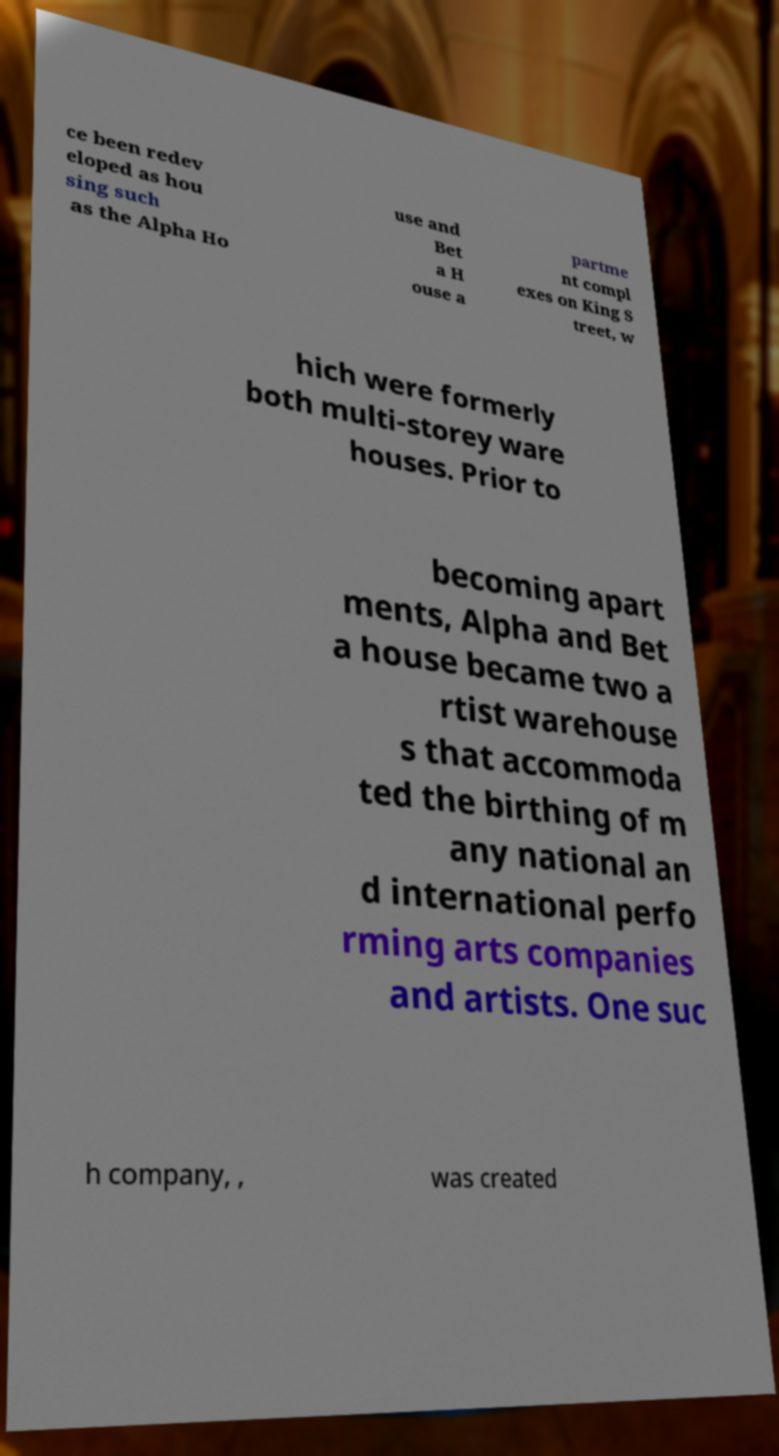Can you read and provide the text displayed in the image?This photo seems to have some interesting text. Can you extract and type it out for me? ce been redev eloped as hou sing such as the Alpha Ho use and Bet a H ouse a partme nt compl exes on King S treet, w hich were formerly both multi-storey ware houses. Prior to becoming apart ments, Alpha and Bet a house became two a rtist warehouse s that accommoda ted the birthing of m any national an d international perfo rming arts companies and artists. One suc h company, , was created 